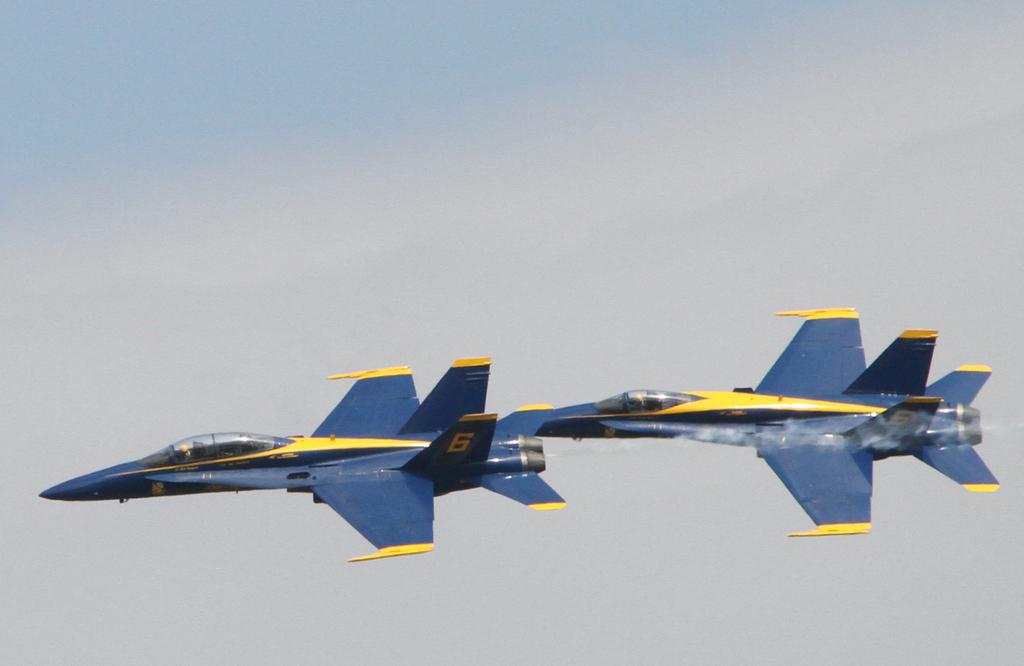What number is the plane on the left?
Make the answer very short. 6. 6 is the number of the plane?
Give a very brief answer. Yes. 